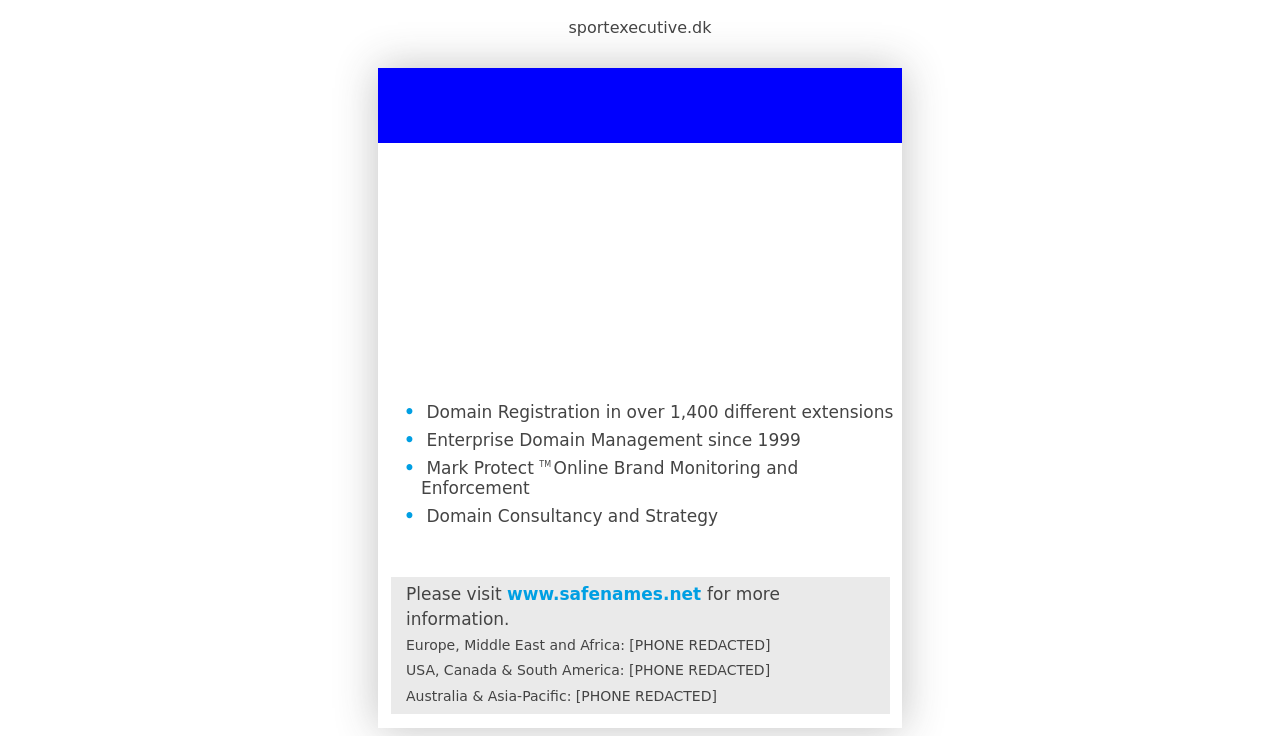What might be the importance of having a visually clean and structured page layout as seen in this image? A clean and structured page layout, as displayed in the image, is crucial for several reasons. Firstly, it enhances user experience by making information easy to find and digest, which is essential for keeping visitors engaged and reducing bounce rates. Secondly, such clarity and organization project professionalism and credibility, which are vital for building trust with potential clients. Lastly, a well-organized website can significantly improve search engine optimization (SEO) as it allows search engines to better understand the site content and structure, potentially leading to higher search rankings. 